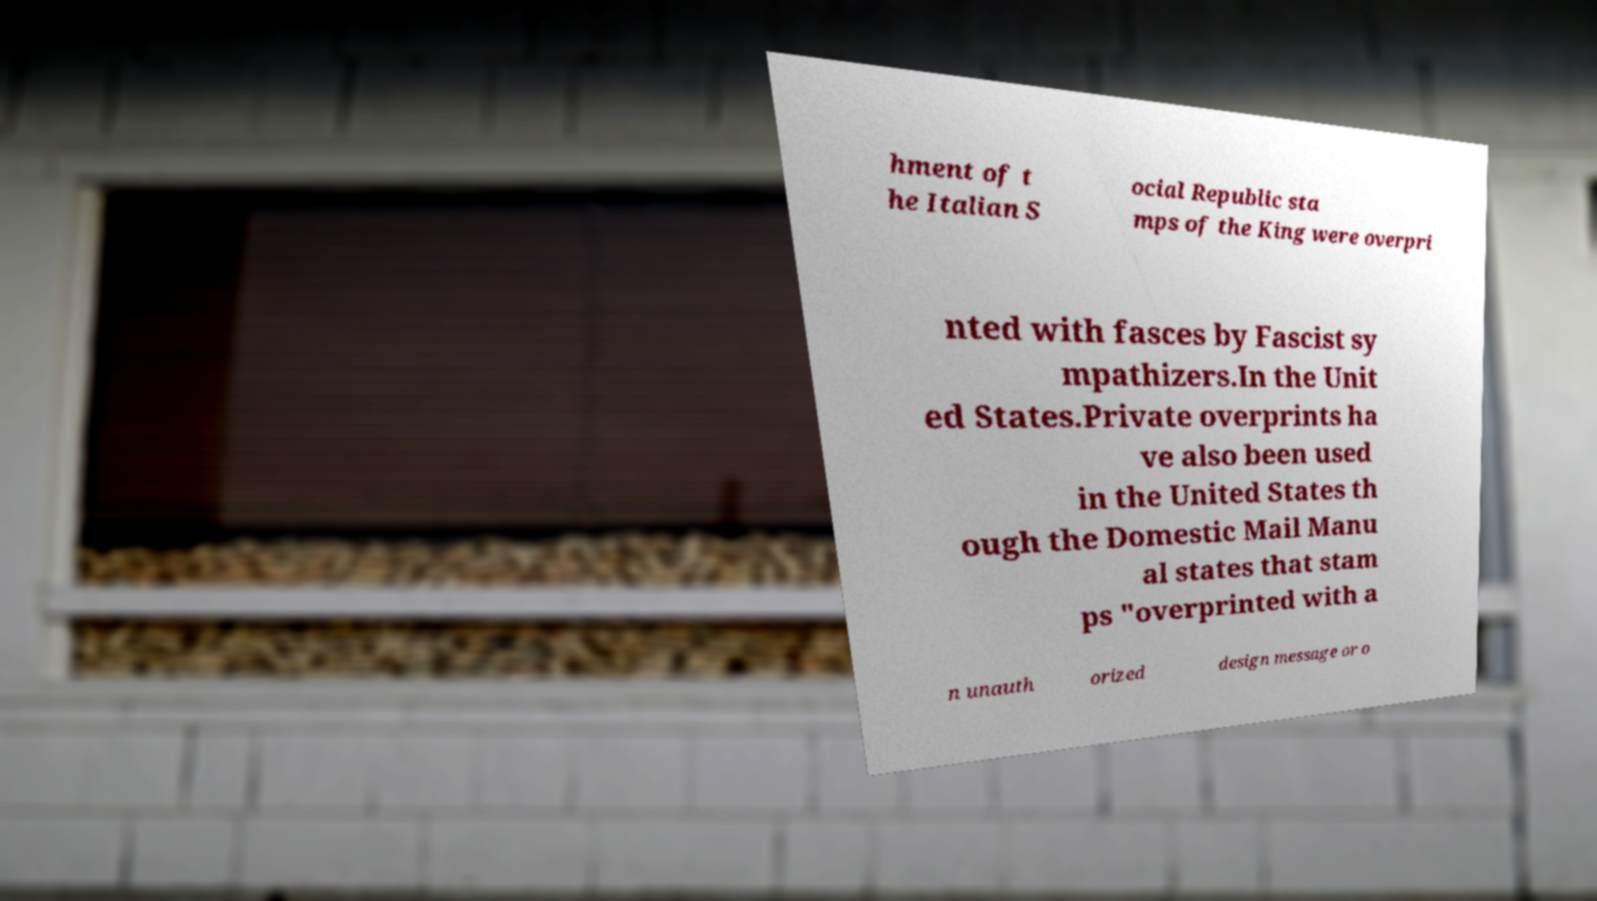Please read and relay the text visible in this image. What does it say? hment of t he Italian S ocial Republic sta mps of the King were overpri nted with fasces by Fascist sy mpathizers.In the Unit ed States.Private overprints ha ve also been used in the United States th ough the Domestic Mail Manu al states that stam ps "overprinted with a n unauth orized design message or o 